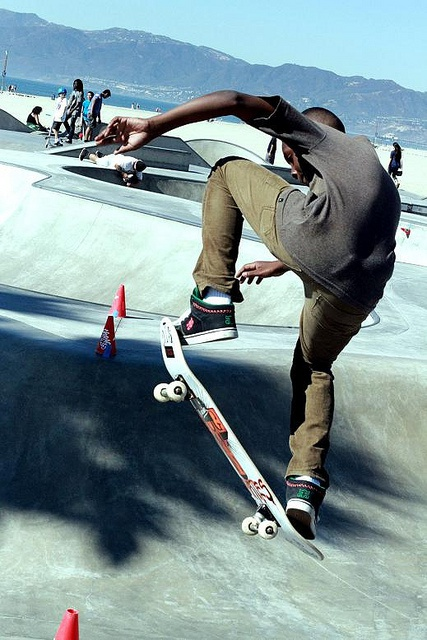Describe the objects in this image and their specific colors. I can see people in lightblue, black, gray, darkgray, and tan tones, skateboard in lightblue, white, darkgray, black, and gray tones, people in lightblue, white, black, gray, and darkgray tones, people in lightblue, black, gray, darkgray, and lightgray tones, and people in lightblue, black, lightgray, gray, and darkgray tones in this image. 